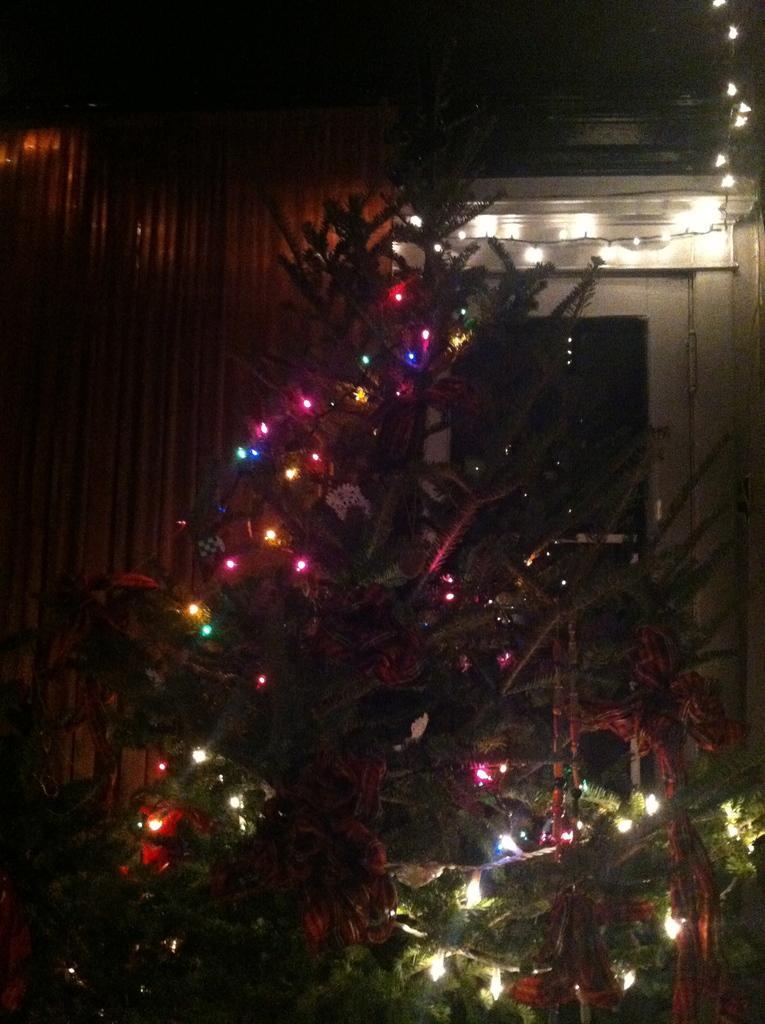Could you give a brief overview of what you see in this image? In this image we can see decorative lights on a tree. In the background the image is dark but we can see decorative lights, objects and wall. 